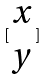<formula> <loc_0><loc_0><loc_500><loc_500>[ \begin{matrix} x \\ y \end{matrix} ]</formula> 